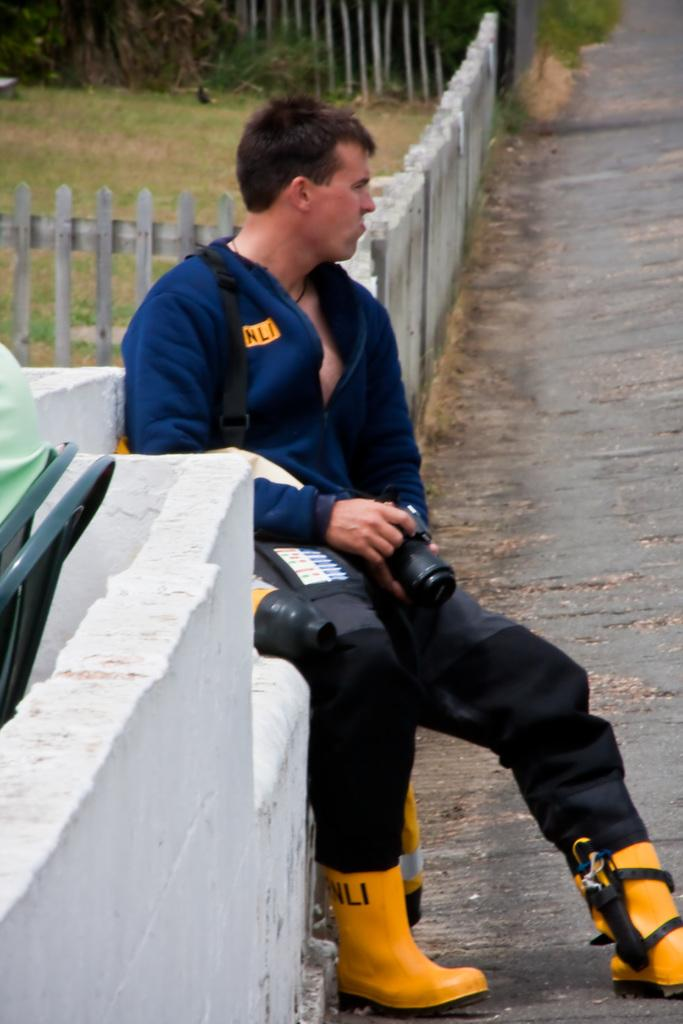What is the main subject of the image? There is a man in the image. What is the man doing in the image? The man is seated in the image. What object is the man holding in his hand? The man is holding a camera in his hand. What type of linen is draped over the man's shoulders in the image? There is no linen draped over the man's shoulders in the image. What kind of grain is visible in the background of the image? There is no grain visible in the background of the image. 